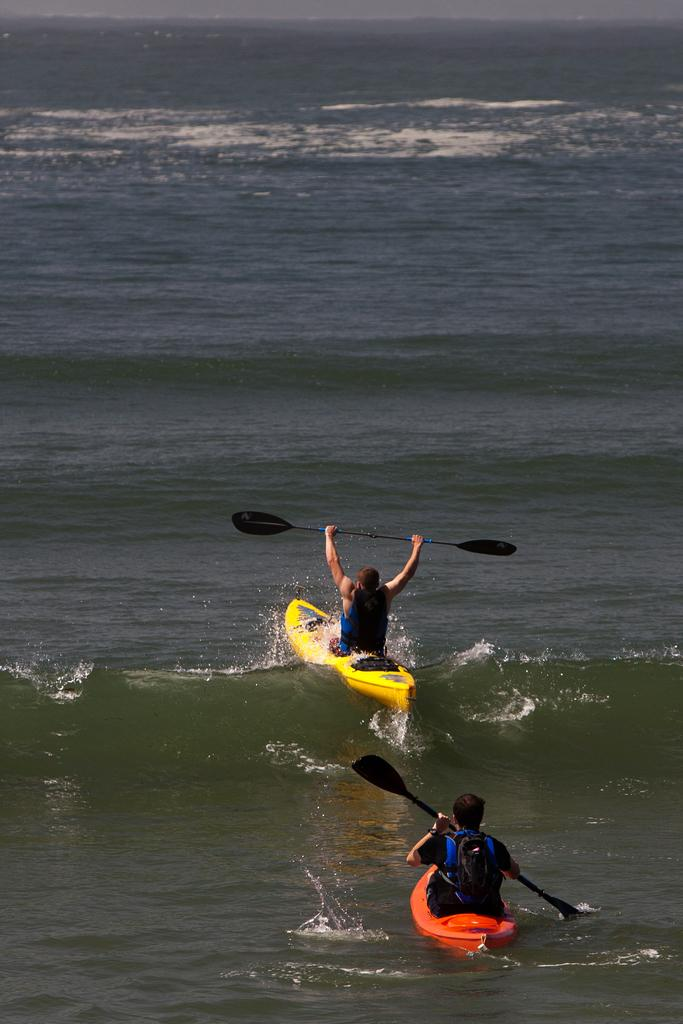How many people are in the image? There are two persons in the image. What are the persons doing in the image? The persons are boating in the water. What color are the dresses of the persons in the image? They are wearing blue color dress. What are the persons holding in the image? They are holding a stick. What grade did the persons receive for their performance in the image? There is no indication of a performance or grade in the image; it simply shows two people boating while wearing blue dresses and holding sticks. 